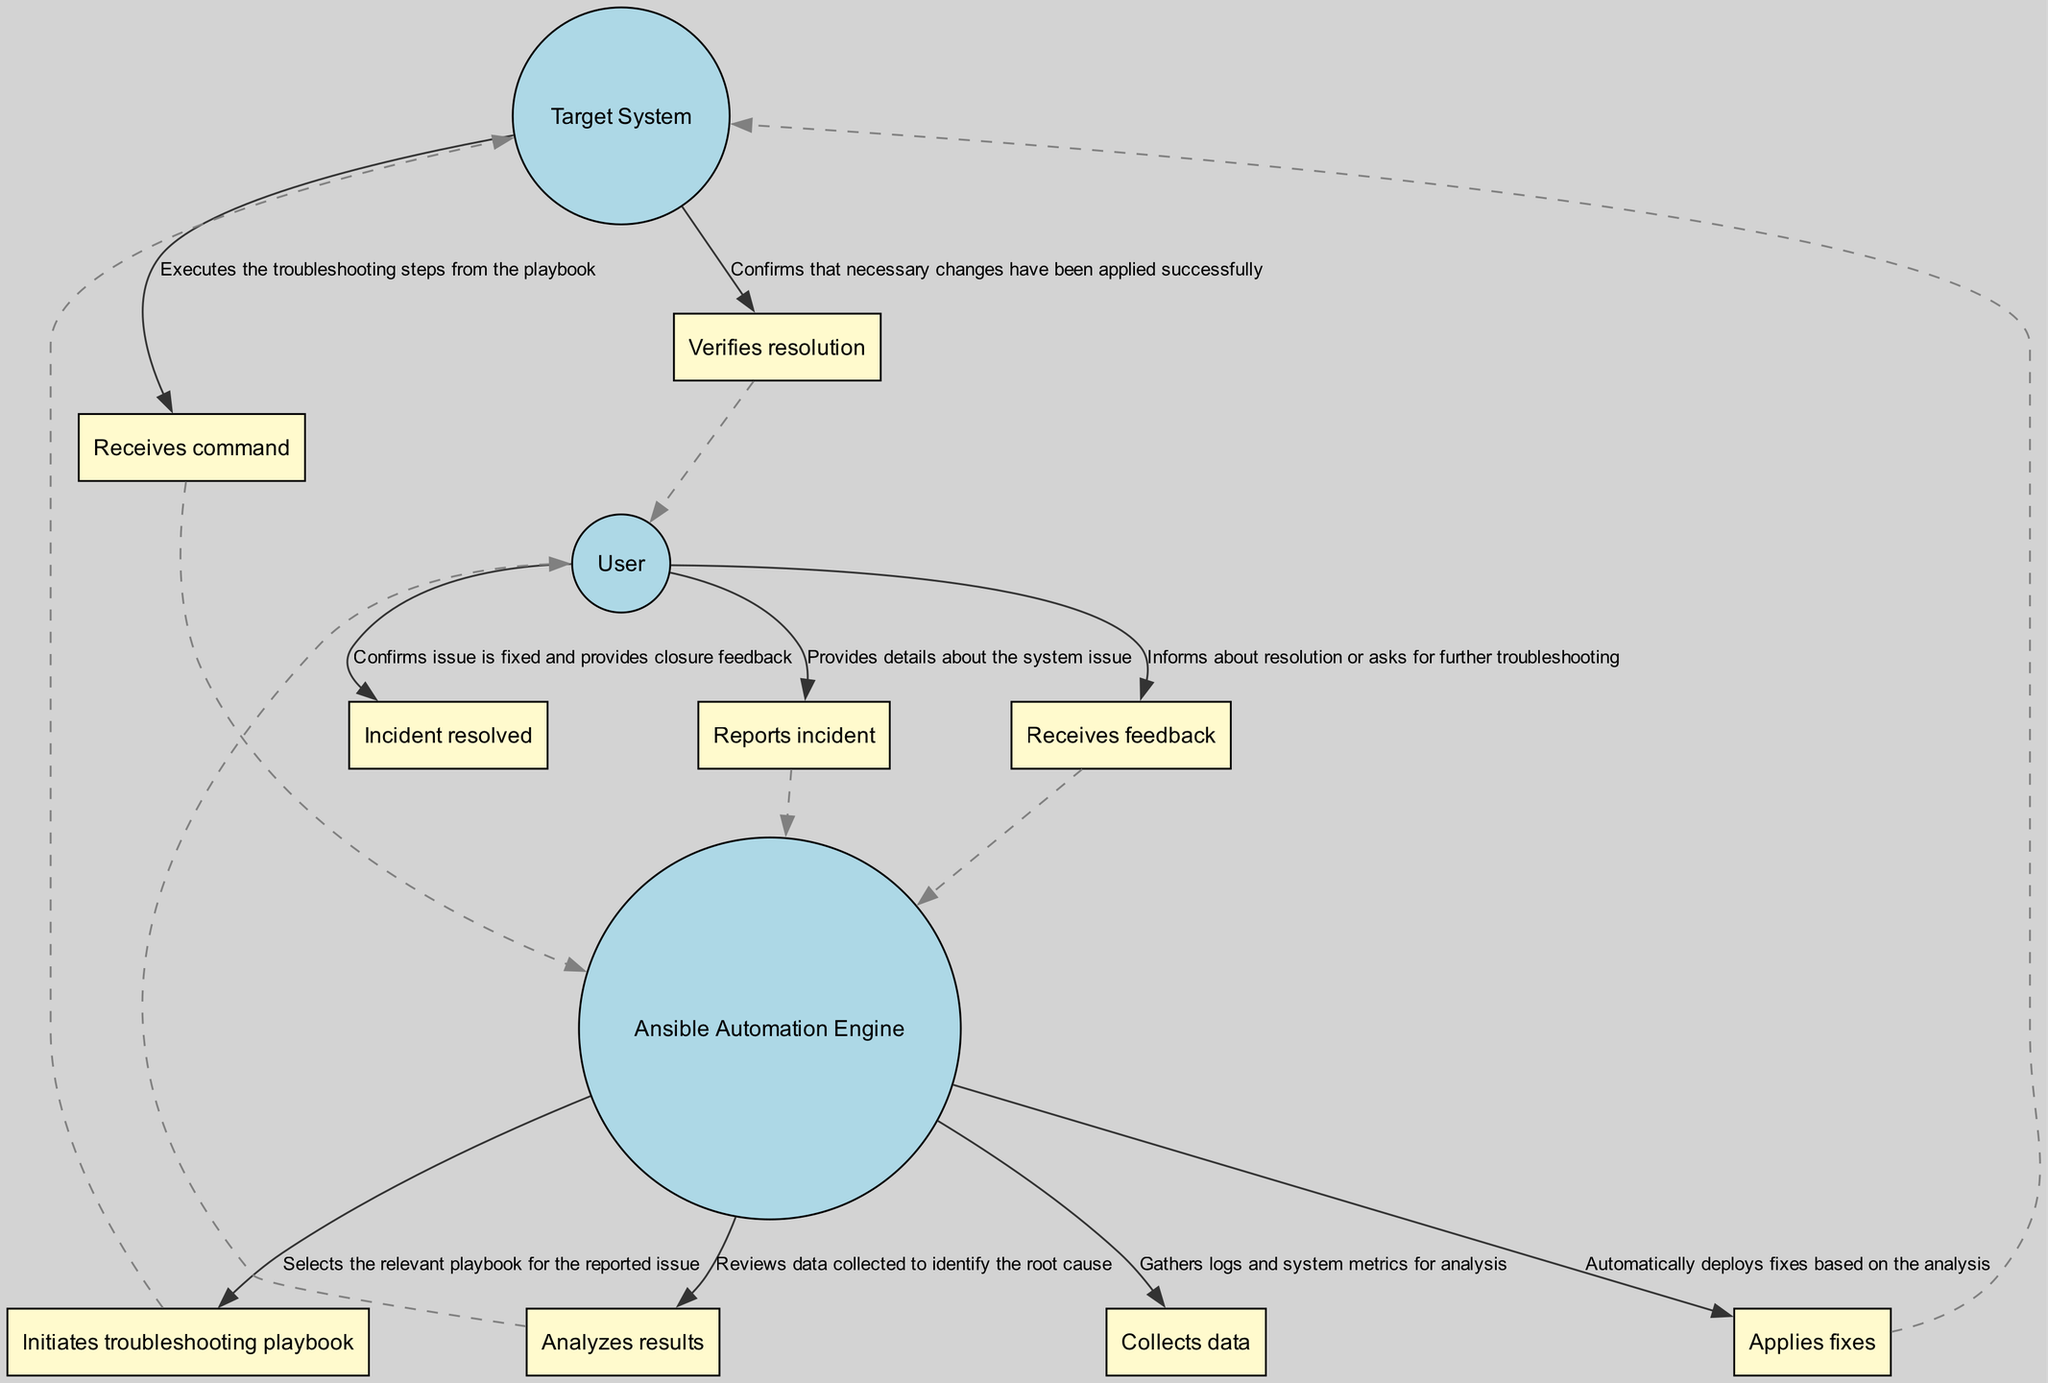What is the first action taken by the User? The first action taken by the User, as indicated in the diagram, is to report an incident, providing details about the system issue.
Answer: Reports incident How many actors are involved in the incident resolution process? By examining the diagram, we can see there are three distinct actors: User, Ansible Automation Engine, and Target System.
Answer: Three What action does the Ansible Automation Engine take after collecting data? After collecting data, the Ansible Automation Engine analyzes the results to identify the root cause of the system issue.
Answer: Analyzes results Who provides closure feedback to confirm the incident resolution? The closure feedback confirming the incident resolution comes from the User, who indicates that the issue is fixed.
Answer: User What happens immediately after the Ansible Automation Engine applies fixes? Following the application of fixes by the Ansible Automation Engine, the Target System verifies that the necessary changes have been applied successfully.
Answer: Verifies resolution How many commands are executed by the Target System? The Target System executes one command, which encompasses all the troubleshooting steps included in the playbook initiated by the Ansible Automation Engine.
Answer: One 